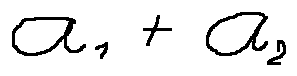<formula> <loc_0><loc_0><loc_500><loc_500>a _ { 1 } + a _ { 2 }</formula> 